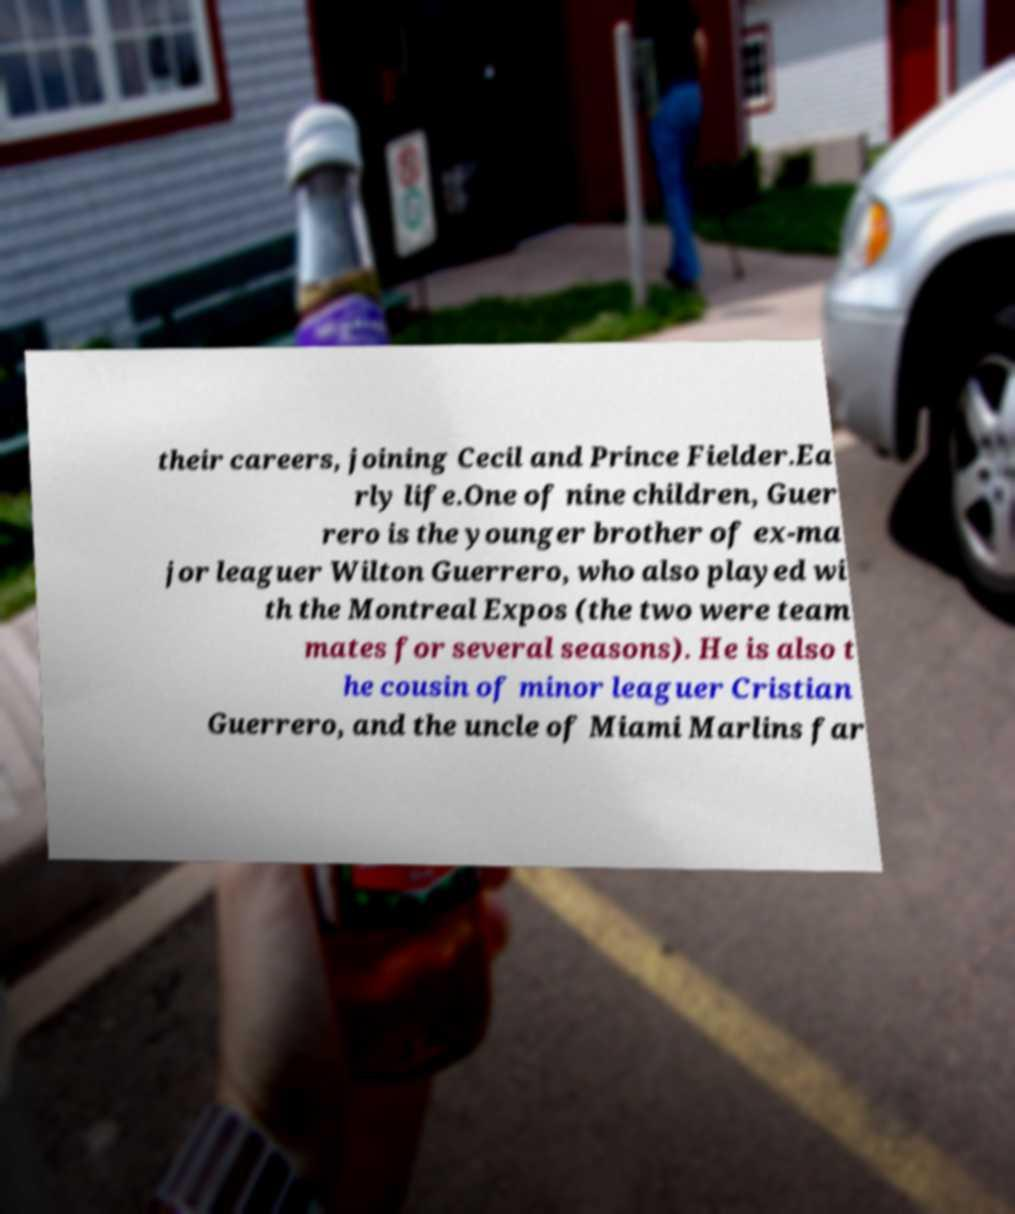Please read and relay the text visible in this image. What does it say? their careers, joining Cecil and Prince Fielder.Ea rly life.One of nine children, Guer rero is the younger brother of ex-ma jor leaguer Wilton Guerrero, who also played wi th the Montreal Expos (the two were team mates for several seasons). He is also t he cousin of minor leaguer Cristian Guerrero, and the uncle of Miami Marlins far 